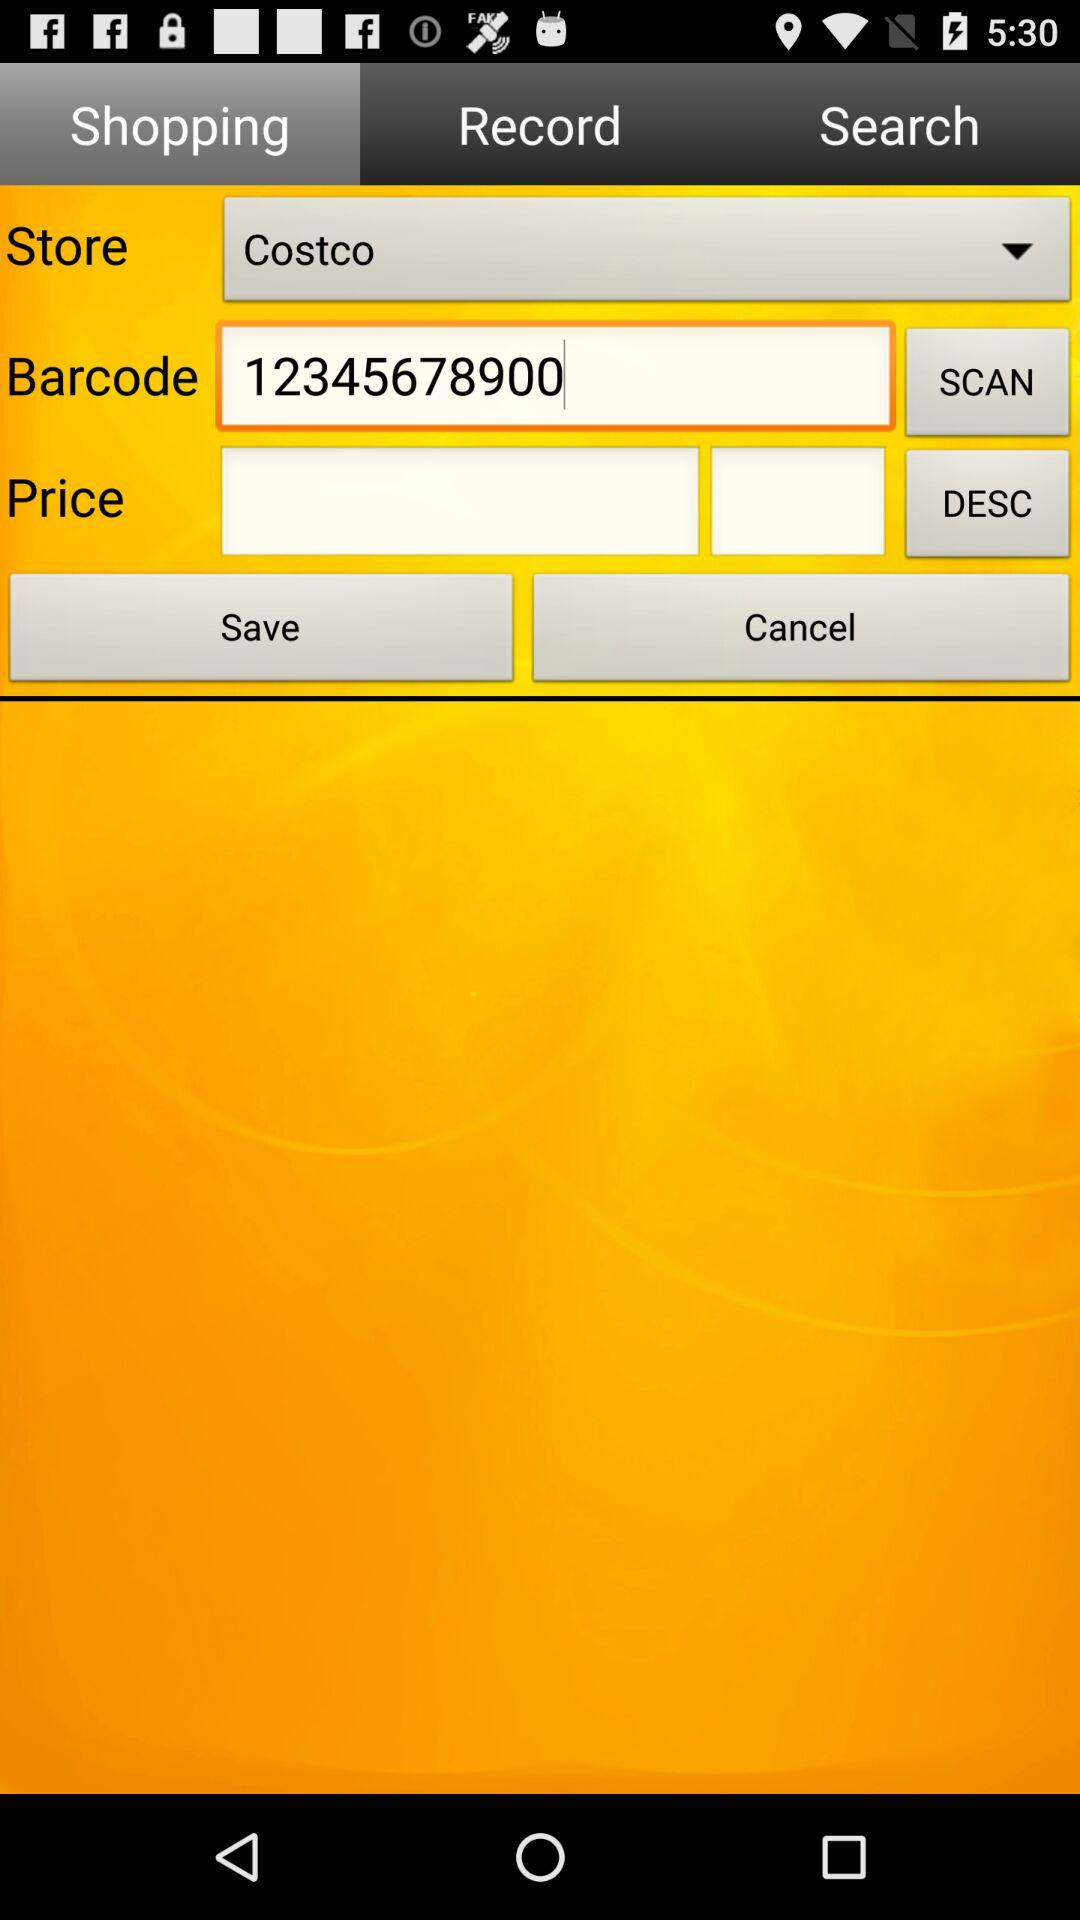Which tab are we on? You are on the "Shopping" tab. 